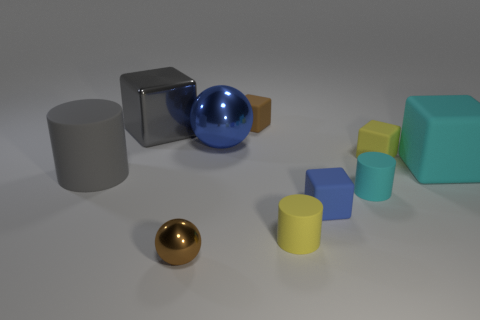There is a big object in front of the big block that is on the right side of the big blue thing; what is its material?
Give a very brief answer. Rubber. The matte object that is the same color as the big sphere is what shape?
Provide a short and direct response. Cube. Is there a big yellow sphere that has the same material as the yellow block?
Provide a succinct answer. No. Is the small cyan object made of the same material as the brown thing that is behind the large cyan block?
Provide a succinct answer. Yes. The metallic object that is the same size as the blue ball is what color?
Offer a terse response. Gray. There is a cyan matte thing behind the tiny matte cylinder behind the yellow rubber cylinder; what size is it?
Provide a succinct answer. Large. There is a large ball; does it have the same color as the tiny matte object in front of the blue matte object?
Give a very brief answer. No. Are there fewer brown objects that are behind the big matte block than blue balls?
Ensure brevity in your answer.  No. What number of other objects are the same size as the gray metallic thing?
Your answer should be very brief. 3. There is a blue object that is left of the blue cube; is it the same shape as the gray shiny thing?
Your response must be concise. No. 